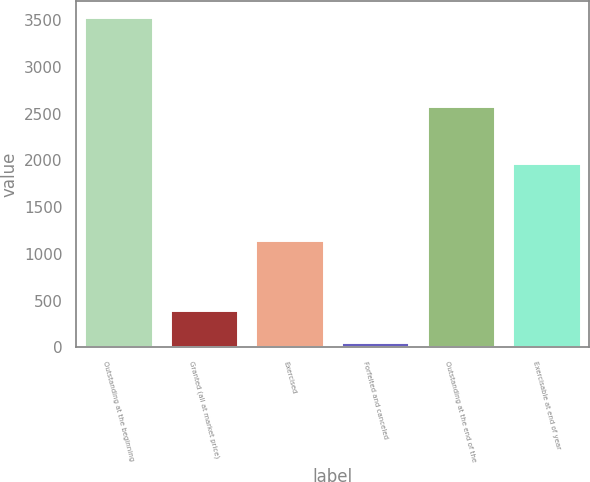Convert chart. <chart><loc_0><loc_0><loc_500><loc_500><bar_chart><fcel>Outstanding at the beginning<fcel>Granted (all at market price)<fcel>Exercised<fcel>Forfeited and canceled<fcel>Outstanding at the end of the<fcel>Exercisable at end of year<nl><fcel>3530<fcel>402.5<fcel>1145<fcel>55<fcel>2579<fcel>1970<nl></chart> 